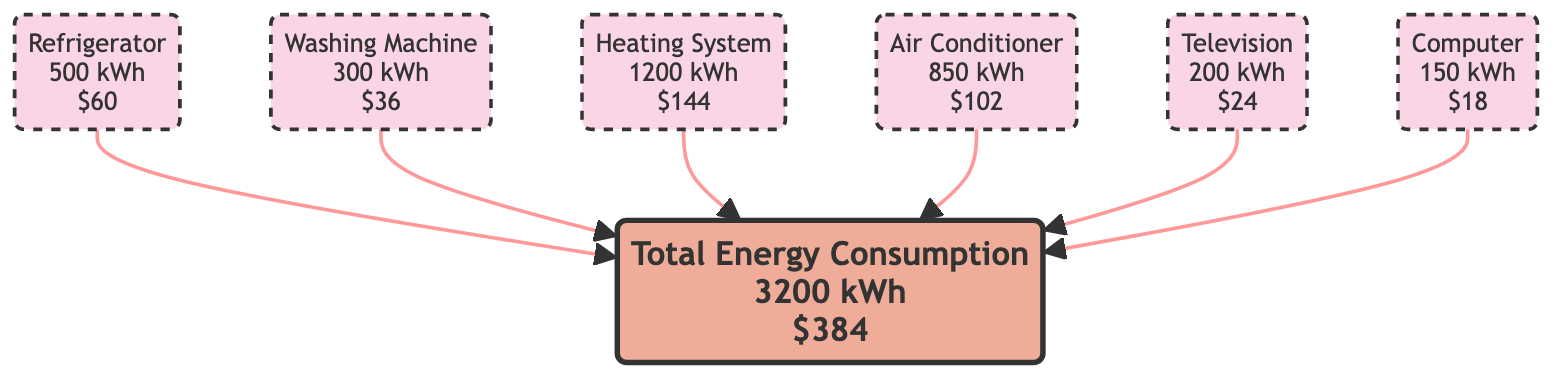What is the annual energy consumption of the Heating System? According to the diagram, the Heating System node displays "1200 kWh" as its annual energy consumption.
Answer: 1200 kWh What is the annual cost of the Air Conditioner? The Air Conditioner node indicates an annual cost of "$102".
Answer: $102 How many appliances are listed in the diagram? By counting the nodes representing appliances, there are a total of six nodes (Refrigerator, Washing Machine, Heating System, Air Conditioner, Television, Computer).
Answer: 6 Which appliance has the lowest annual cost? Among the appliance nodes, the Computer node shows an annual cost of "$18," which is the least among all listed costs.
Answer: $18 What is the total annual energy consumption for all appliances? The Total Energy Consumption node aggregates the energy and indicates "3200 kWh" as the total annual energy consumption for all appliances combined.
Answer: 3200 kWh What is the sum of costs for the Refrigerator and Television? The Refrigerator costs "$60" and the Television costs "$24." Adding these two amounts together gives "$84".
Answer: $84 Which appliance uses the most energy? The Heating System node shows "1200 kWh," making it the appliance with the highest energy consumption when comparing all appliances in the diagram.
Answer: Heating System How much does the Computer cost per kWh? The Computer node lists a cost per kWh of "$0.12," which is the same for all the appliances in the diagram.
Answer: $0.12 Which node connects to Total Energy? All appliances connect to the Total Energy node; they are: Refrigerator, Washing Machine, Heating System, Air Conditioner, Television, and Computer.
Answer: All appliances 